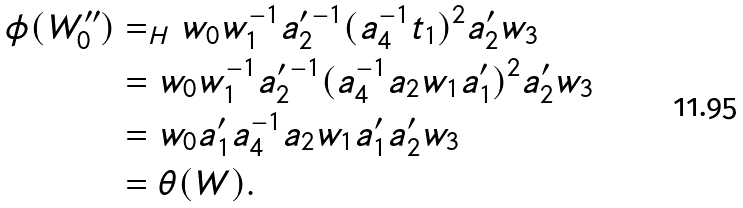<formula> <loc_0><loc_0><loc_500><loc_500>\phi ( W ^ { \prime \prime } _ { 0 } ) & = _ { H } w _ { 0 } w _ { 1 } ^ { - 1 } a _ { 2 } ^ { \prime \, - 1 } ( a _ { 4 } ^ { - 1 } t _ { 1 } ) ^ { 2 } a ^ { \prime } _ { 2 } w _ { 3 } \\ & = w _ { 0 } w _ { 1 } ^ { - 1 } a _ { 2 } ^ { \prime \, - 1 } ( a _ { 4 } ^ { - 1 } a _ { 2 } w _ { 1 } a ^ { \prime } _ { 1 } ) ^ { 2 } a ^ { \prime } _ { 2 } w _ { 3 } \\ & = w _ { 0 } a ^ { \prime } _ { 1 } a _ { 4 } ^ { - 1 } a _ { 2 } w _ { 1 } a ^ { \prime } _ { 1 } a ^ { \prime } _ { 2 } w _ { 3 } \\ & = \theta ( W ) .</formula> 